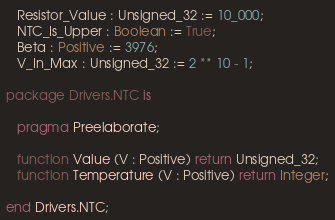<code> <loc_0><loc_0><loc_500><loc_500><_Ada_>
   Resistor_Value : Unsigned_32 := 10_000;
   NTC_Is_Upper : Boolean := True;
   Beta : Positive := 3976;
   V_In_Max : Unsigned_32 := 2 ** 10 - 1;

package Drivers.NTC is

   pragma Preelaborate;

   function Value (V : Positive) return Unsigned_32;
   function Temperature (V : Positive) return Integer;

end Drivers.NTC;
</code> 